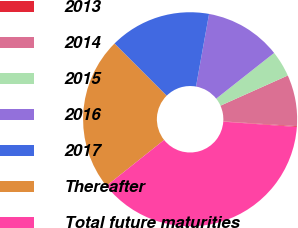Convert chart. <chart><loc_0><loc_0><loc_500><loc_500><pie_chart><fcel>2013<fcel>2014<fcel>2015<fcel>2016<fcel>2017<fcel>Thereafter<fcel>Total future maturities<nl><fcel>0.12%<fcel>7.73%<fcel>3.93%<fcel>11.53%<fcel>15.33%<fcel>23.2%<fcel>38.15%<nl></chart> 